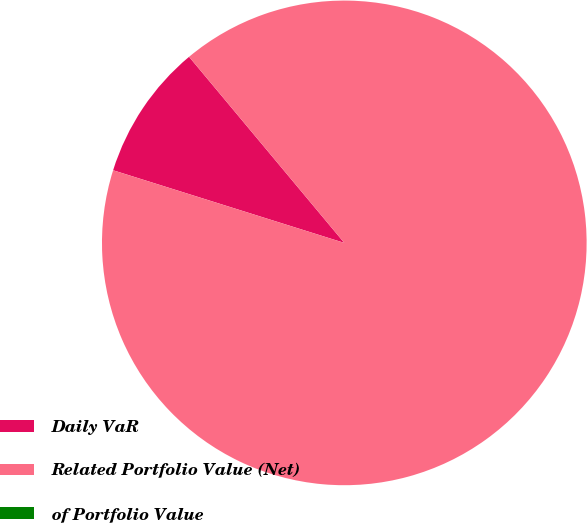<chart> <loc_0><loc_0><loc_500><loc_500><pie_chart><fcel>Daily VaR<fcel>Related Portfolio Value (Net)<fcel>of Portfolio Value<nl><fcel>9.09%<fcel>90.91%<fcel>0.0%<nl></chart> 